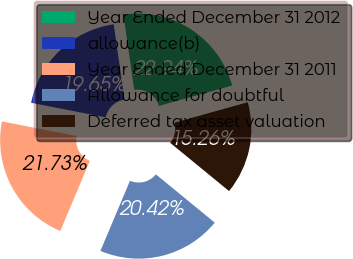Convert chart. <chart><loc_0><loc_0><loc_500><loc_500><pie_chart><fcel>Year Ended December 31 2012<fcel>allowance(b)<fcel>Year Ended December 31 2011<fcel>Allowance for doubtful<fcel>Deferred tax asset valuation<nl><fcel>22.94%<fcel>19.65%<fcel>21.73%<fcel>20.42%<fcel>15.26%<nl></chart> 